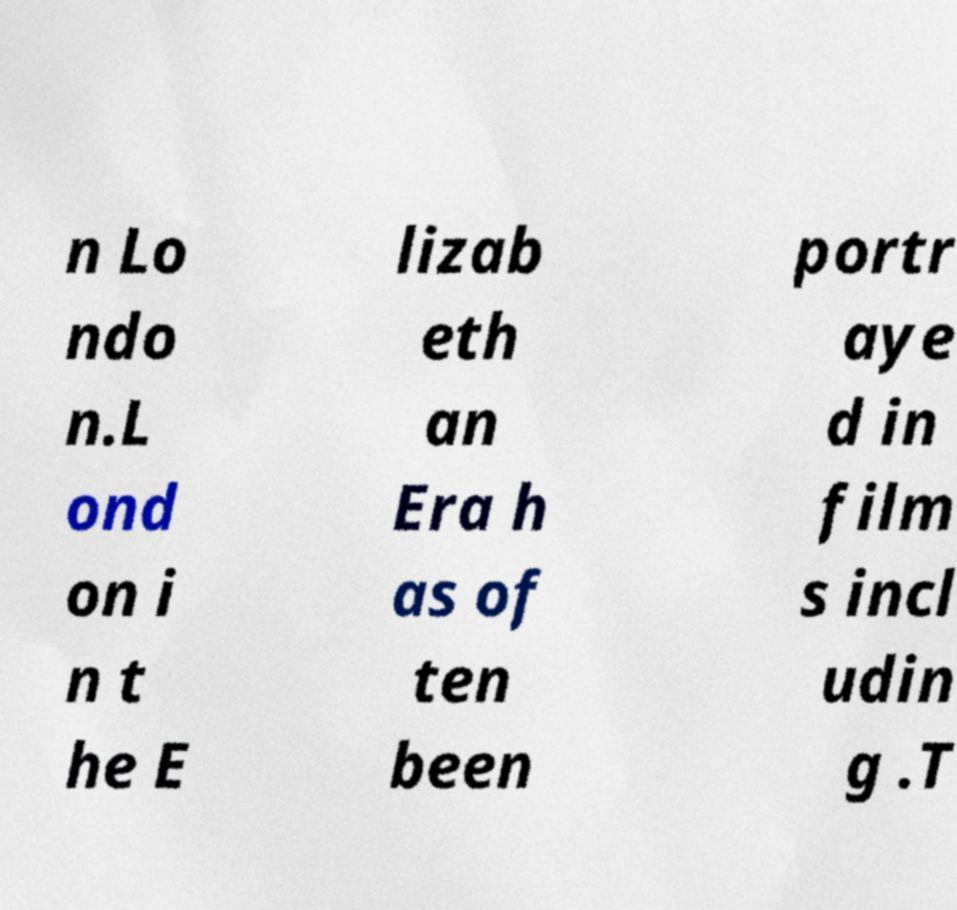What messages or text are displayed in this image? I need them in a readable, typed format. n Lo ndo n.L ond on i n t he E lizab eth an Era h as of ten been portr aye d in film s incl udin g .T 